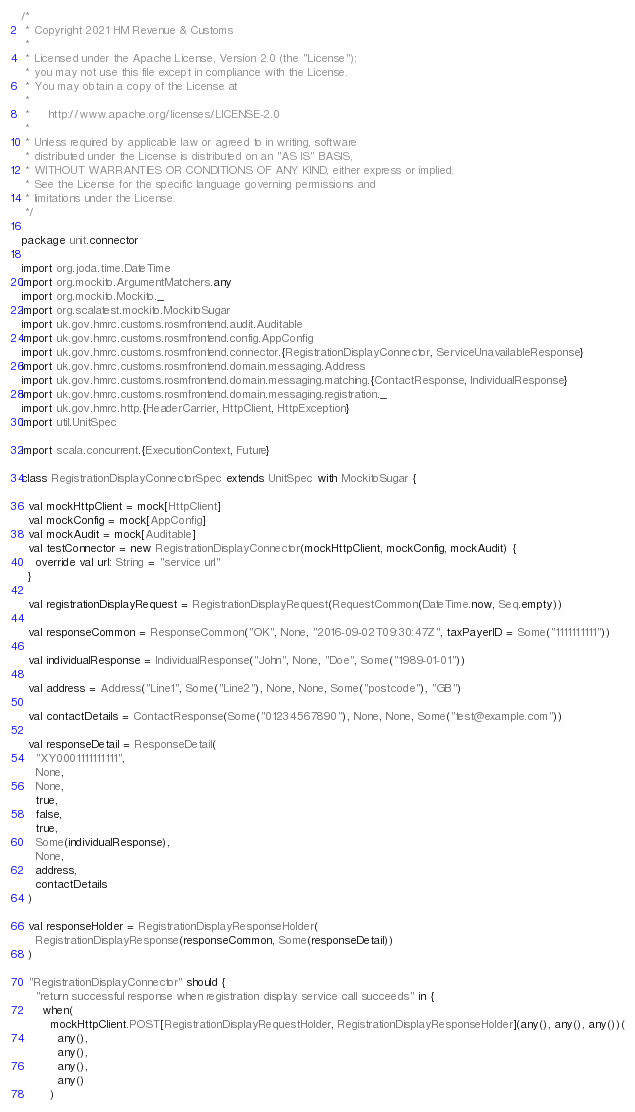<code> <loc_0><loc_0><loc_500><loc_500><_Scala_>/*
 * Copyright 2021 HM Revenue & Customs
 *
 * Licensed under the Apache License, Version 2.0 (the "License");
 * you may not use this file except in compliance with the License.
 * You may obtain a copy of the License at
 *
 *     http://www.apache.org/licenses/LICENSE-2.0
 *
 * Unless required by applicable law or agreed to in writing, software
 * distributed under the License is distributed on an "AS IS" BASIS,
 * WITHOUT WARRANTIES OR CONDITIONS OF ANY KIND, either express or implied.
 * See the License for the specific language governing permissions and
 * limitations under the License.
 */

package unit.connector

import org.joda.time.DateTime
import org.mockito.ArgumentMatchers.any
import org.mockito.Mockito._
import org.scalatest.mockito.MockitoSugar
import uk.gov.hmrc.customs.rosmfrontend.audit.Auditable
import uk.gov.hmrc.customs.rosmfrontend.config.AppConfig
import uk.gov.hmrc.customs.rosmfrontend.connector.{RegistrationDisplayConnector, ServiceUnavailableResponse}
import uk.gov.hmrc.customs.rosmfrontend.domain.messaging.Address
import uk.gov.hmrc.customs.rosmfrontend.domain.messaging.matching.{ContactResponse, IndividualResponse}
import uk.gov.hmrc.customs.rosmfrontend.domain.messaging.registration._
import uk.gov.hmrc.http.{HeaderCarrier, HttpClient, HttpException}
import util.UnitSpec

import scala.concurrent.{ExecutionContext, Future}

class RegistrationDisplayConnectorSpec extends UnitSpec with MockitoSugar {

  val mockHttpClient = mock[HttpClient]
  val mockConfig = mock[AppConfig]
  val mockAudit = mock[Auditable]
  val testConnector = new RegistrationDisplayConnector(mockHttpClient, mockConfig, mockAudit) {
    override val url: String = "service url"
  }

  val registrationDisplayRequest = RegistrationDisplayRequest(RequestCommon(DateTime.now, Seq.empty))

  val responseCommon = ResponseCommon("OK", None, "2016-09-02T09:30:47Z", taxPayerID = Some("1111111111"))

  val individualResponse = IndividualResponse("John", None, "Doe", Some("1989-01-01"))

  val address = Address("Line1", Some("Line2"), None, None, Some("postcode"), "GB")

  val contactDetails = ContactResponse(Some("01234567890"), None, None, Some("test@example.com"))

  val responseDetail = ResponseDetail(
    "XY0001111111111",
    None,
    None,
    true,
    false,
    true,
    Some(individualResponse),
    None,
    address,
    contactDetails
  )

  val responseHolder = RegistrationDisplayResponseHolder(
    RegistrationDisplayResponse(responseCommon, Some(responseDetail))
  )

  "RegistrationDisplayConnector" should {
    "return successful response when registration display service call succeeds" in {
      when(
        mockHttpClient.POST[RegistrationDisplayRequestHolder, RegistrationDisplayResponseHolder](any(), any(), any())(
          any(),
          any(),
          any(),
          any()
        )</code> 